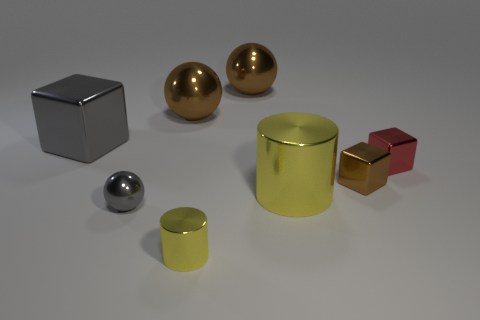How many brown spheres must be subtracted to get 1 brown spheres? 1 Add 1 big yellow cylinders. How many objects exist? 9 Subtract all cylinders. How many objects are left? 6 Add 7 green rubber cylinders. How many green rubber cylinders exist? 7 Subtract 0 cyan blocks. How many objects are left? 8 Subtract all big gray shiny cylinders. Subtract all big yellow metal cylinders. How many objects are left? 7 Add 4 big cylinders. How many big cylinders are left? 5 